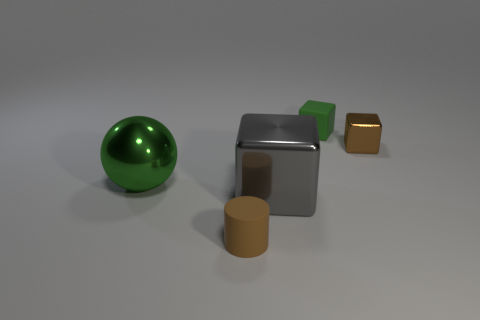Subtract all green blocks. How many blocks are left? 2 Add 4 brown rubber cubes. How many objects exist? 9 Subtract 1 cubes. How many cubes are left? 2 Subtract all spheres. How many objects are left? 4 Subtract all purple cubes. Subtract all brown spheres. How many cubes are left? 3 Add 4 large green things. How many large green things exist? 5 Subtract 0 blue blocks. How many objects are left? 5 Subtract all big brown metallic cylinders. Subtract all small objects. How many objects are left? 2 Add 5 tiny matte things. How many tiny matte things are left? 7 